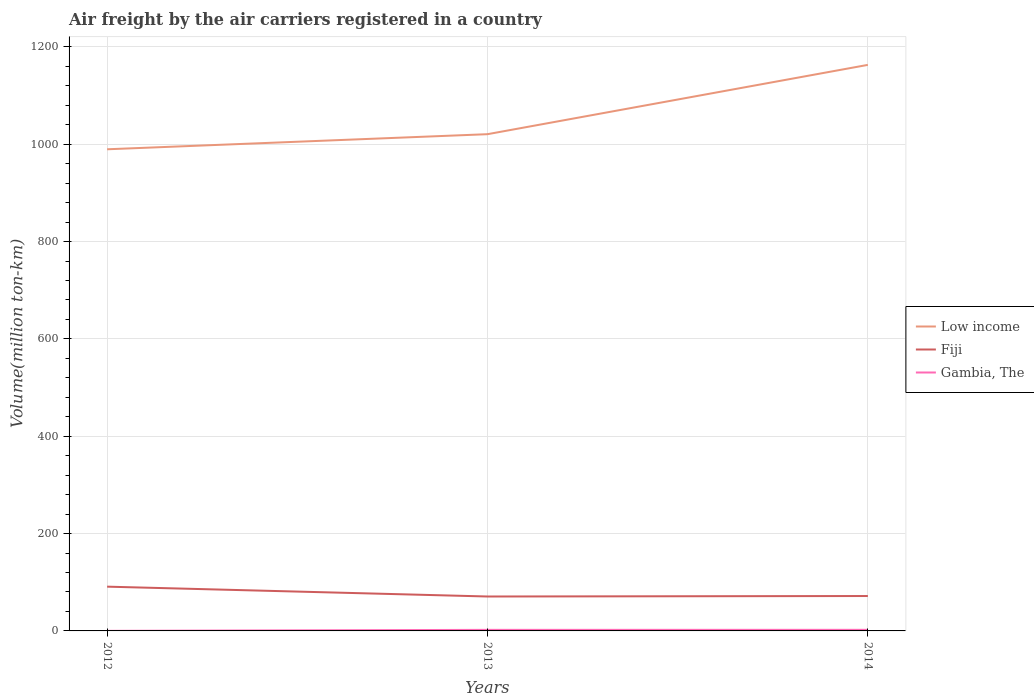Does the line corresponding to Gambia, The intersect with the line corresponding to Fiji?
Provide a succinct answer. No. Across all years, what is the maximum volume of the air carriers in Gambia, The?
Give a very brief answer. 0.16. What is the total volume of the air carriers in Fiji in the graph?
Your response must be concise. 19.21. What is the difference between the highest and the second highest volume of the air carriers in Fiji?
Offer a very short reply. 20.21. How many years are there in the graph?
Your answer should be very brief. 3. What is the difference between two consecutive major ticks on the Y-axis?
Give a very brief answer. 200. Does the graph contain any zero values?
Give a very brief answer. No. Does the graph contain grids?
Your answer should be very brief. Yes. How many legend labels are there?
Your answer should be compact. 3. What is the title of the graph?
Ensure brevity in your answer.  Air freight by the air carriers registered in a country. What is the label or title of the X-axis?
Provide a succinct answer. Years. What is the label or title of the Y-axis?
Offer a terse response. Volume(million ton-km). What is the Volume(million ton-km) in Low income in 2012?
Give a very brief answer. 989.65. What is the Volume(million ton-km) of Fiji in 2012?
Offer a very short reply. 90.94. What is the Volume(million ton-km) of Gambia, The in 2012?
Provide a short and direct response. 0.16. What is the Volume(million ton-km) in Low income in 2013?
Provide a short and direct response. 1020.66. What is the Volume(million ton-km) of Fiji in 2013?
Provide a succinct answer. 70.73. What is the Volume(million ton-km) in Gambia, The in 2013?
Your answer should be very brief. 2.17. What is the Volume(million ton-km) in Low income in 2014?
Keep it short and to the point. 1163.09. What is the Volume(million ton-km) of Fiji in 2014?
Provide a short and direct response. 71.73. What is the Volume(million ton-km) in Gambia, The in 2014?
Provide a short and direct response. 2.25. Across all years, what is the maximum Volume(million ton-km) in Low income?
Provide a short and direct response. 1163.09. Across all years, what is the maximum Volume(million ton-km) of Fiji?
Provide a short and direct response. 90.94. Across all years, what is the maximum Volume(million ton-km) in Gambia, The?
Ensure brevity in your answer.  2.25. Across all years, what is the minimum Volume(million ton-km) of Low income?
Keep it short and to the point. 989.65. Across all years, what is the minimum Volume(million ton-km) of Fiji?
Offer a very short reply. 70.73. Across all years, what is the minimum Volume(million ton-km) in Gambia, The?
Make the answer very short. 0.16. What is the total Volume(million ton-km) of Low income in the graph?
Your response must be concise. 3173.4. What is the total Volume(million ton-km) in Fiji in the graph?
Give a very brief answer. 233.4. What is the total Volume(million ton-km) in Gambia, The in the graph?
Provide a succinct answer. 4.57. What is the difference between the Volume(million ton-km) in Low income in 2012 and that in 2013?
Make the answer very short. -31.02. What is the difference between the Volume(million ton-km) in Fiji in 2012 and that in 2013?
Offer a very short reply. 20.21. What is the difference between the Volume(million ton-km) of Gambia, The in 2012 and that in 2013?
Offer a terse response. -2.02. What is the difference between the Volume(million ton-km) of Low income in 2012 and that in 2014?
Give a very brief answer. -173.44. What is the difference between the Volume(million ton-km) of Fiji in 2012 and that in 2014?
Ensure brevity in your answer.  19.21. What is the difference between the Volume(million ton-km) of Gambia, The in 2012 and that in 2014?
Provide a short and direct response. -2.09. What is the difference between the Volume(million ton-km) in Low income in 2013 and that in 2014?
Offer a very short reply. -142.43. What is the difference between the Volume(million ton-km) in Fiji in 2013 and that in 2014?
Make the answer very short. -1. What is the difference between the Volume(million ton-km) of Gambia, The in 2013 and that in 2014?
Your answer should be compact. -0.07. What is the difference between the Volume(million ton-km) in Low income in 2012 and the Volume(million ton-km) in Fiji in 2013?
Your response must be concise. 918.92. What is the difference between the Volume(million ton-km) of Low income in 2012 and the Volume(million ton-km) of Gambia, The in 2013?
Your answer should be very brief. 987.48. What is the difference between the Volume(million ton-km) of Fiji in 2012 and the Volume(million ton-km) of Gambia, The in 2013?
Give a very brief answer. 88.77. What is the difference between the Volume(million ton-km) in Low income in 2012 and the Volume(million ton-km) in Fiji in 2014?
Your answer should be very brief. 917.92. What is the difference between the Volume(million ton-km) of Low income in 2012 and the Volume(million ton-km) of Gambia, The in 2014?
Give a very brief answer. 987.4. What is the difference between the Volume(million ton-km) of Fiji in 2012 and the Volume(million ton-km) of Gambia, The in 2014?
Make the answer very short. 88.69. What is the difference between the Volume(million ton-km) of Low income in 2013 and the Volume(million ton-km) of Fiji in 2014?
Give a very brief answer. 948.93. What is the difference between the Volume(million ton-km) of Low income in 2013 and the Volume(million ton-km) of Gambia, The in 2014?
Offer a terse response. 1018.42. What is the difference between the Volume(million ton-km) of Fiji in 2013 and the Volume(million ton-km) of Gambia, The in 2014?
Your answer should be very brief. 68.48. What is the average Volume(million ton-km) in Low income per year?
Your answer should be very brief. 1057.8. What is the average Volume(million ton-km) of Fiji per year?
Provide a succinct answer. 77.8. What is the average Volume(million ton-km) in Gambia, The per year?
Your answer should be compact. 1.52. In the year 2012, what is the difference between the Volume(million ton-km) in Low income and Volume(million ton-km) in Fiji?
Keep it short and to the point. 898.71. In the year 2012, what is the difference between the Volume(million ton-km) in Low income and Volume(million ton-km) in Gambia, The?
Provide a succinct answer. 989.49. In the year 2012, what is the difference between the Volume(million ton-km) in Fiji and Volume(million ton-km) in Gambia, The?
Keep it short and to the point. 90.79. In the year 2013, what is the difference between the Volume(million ton-km) in Low income and Volume(million ton-km) in Fiji?
Your answer should be very brief. 949.93. In the year 2013, what is the difference between the Volume(million ton-km) of Low income and Volume(million ton-km) of Gambia, The?
Provide a short and direct response. 1018.49. In the year 2013, what is the difference between the Volume(million ton-km) of Fiji and Volume(million ton-km) of Gambia, The?
Offer a very short reply. 68.56. In the year 2014, what is the difference between the Volume(million ton-km) in Low income and Volume(million ton-km) in Fiji?
Give a very brief answer. 1091.36. In the year 2014, what is the difference between the Volume(million ton-km) in Low income and Volume(million ton-km) in Gambia, The?
Ensure brevity in your answer.  1160.85. In the year 2014, what is the difference between the Volume(million ton-km) of Fiji and Volume(million ton-km) of Gambia, The?
Your answer should be very brief. 69.48. What is the ratio of the Volume(million ton-km) of Low income in 2012 to that in 2013?
Make the answer very short. 0.97. What is the ratio of the Volume(million ton-km) in Fiji in 2012 to that in 2013?
Your answer should be very brief. 1.29. What is the ratio of the Volume(million ton-km) of Gambia, The in 2012 to that in 2013?
Keep it short and to the point. 0.07. What is the ratio of the Volume(million ton-km) of Low income in 2012 to that in 2014?
Make the answer very short. 0.85. What is the ratio of the Volume(million ton-km) of Fiji in 2012 to that in 2014?
Make the answer very short. 1.27. What is the ratio of the Volume(million ton-km) of Gambia, The in 2012 to that in 2014?
Keep it short and to the point. 0.07. What is the ratio of the Volume(million ton-km) of Low income in 2013 to that in 2014?
Make the answer very short. 0.88. What is the ratio of the Volume(million ton-km) in Fiji in 2013 to that in 2014?
Your answer should be very brief. 0.99. What is the ratio of the Volume(million ton-km) in Gambia, The in 2013 to that in 2014?
Make the answer very short. 0.97. What is the difference between the highest and the second highest Volume(million ton-km) of Low income?
Offer a very short reply. 142.43. What is the difference between the highest and the second highest Volume(million ton-km) in Fiji?
Offer a very short reply. 19.21. What is the difference between the highest and the second highest Volume(million ton-km) in Gambia, The?
Offer a terse response. 0.07. What is the difference between the highest and the lowest Volume(million ton-km) in Low income?
Your response must be concise. 173.44. What is the difference between the highest and the lowest Volume(million ton-km) of Fiji?
Your response must be concise. 20.21. What is the difference between the highest and the lowest Volume(million ton-km) in Gambia, The?
Your response must be concise. 2.09. 